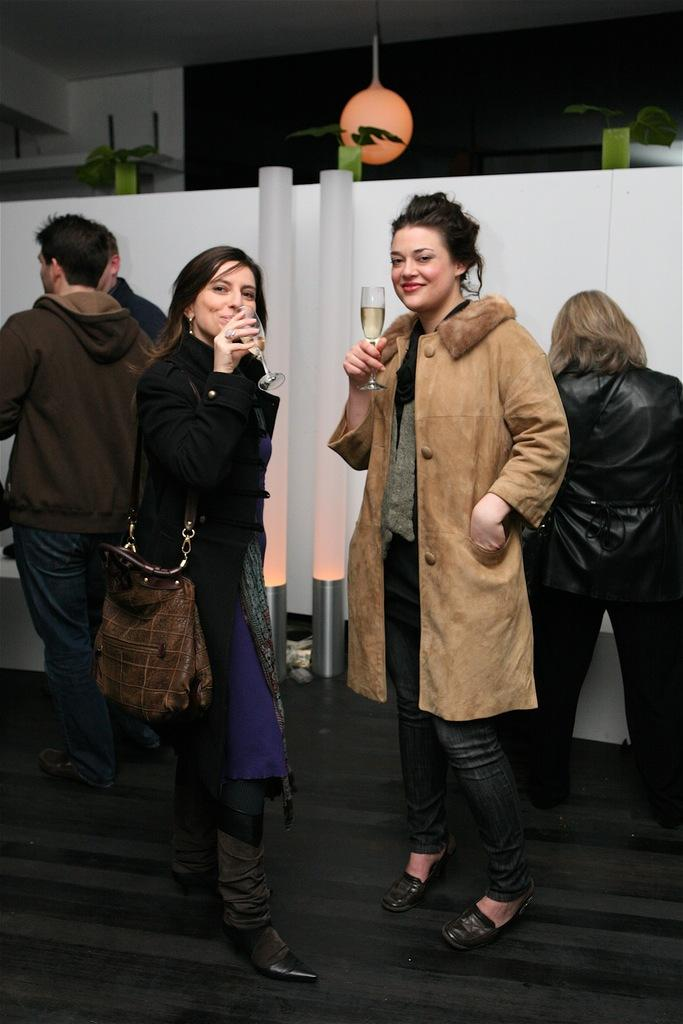What is happening in the image? There are people standing in the image. Can you describe the lighting in the image? There is light visible in the background of the image. What type of rod is being used for development in the image? There is no rod or development process visible in the image; it only shows people standing. 